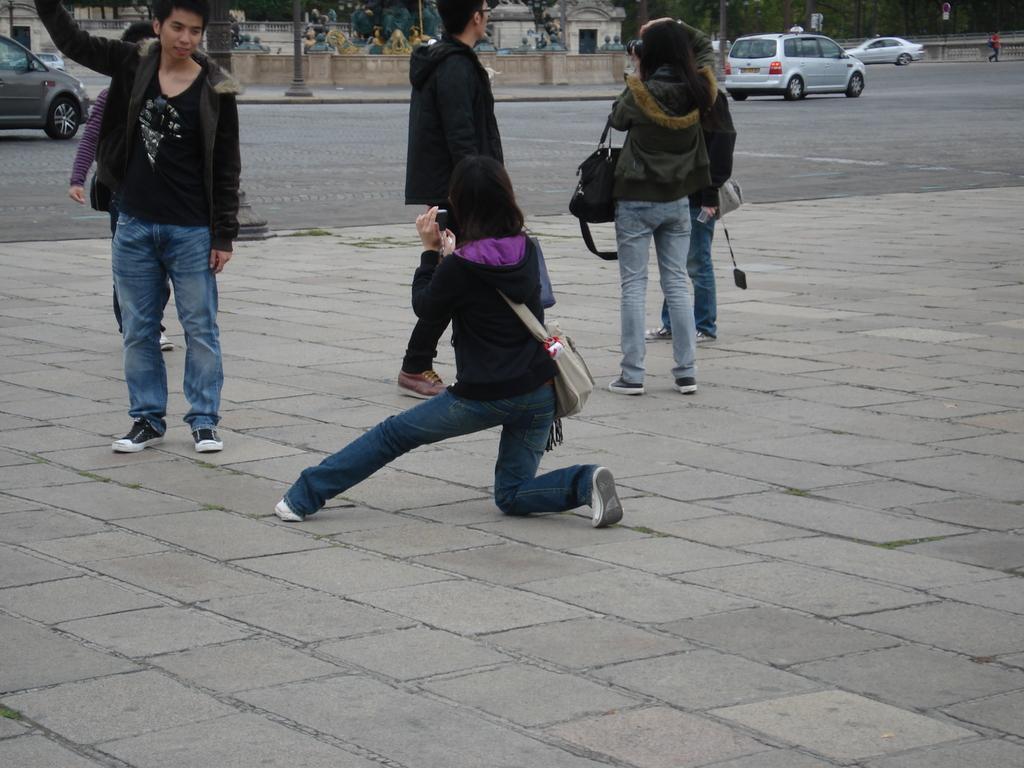Could you give a brief overview of what you see in this image? In this image, we can see persons wearing clothes. There are cars on the road. There is a wall and pole at the top of the image. 